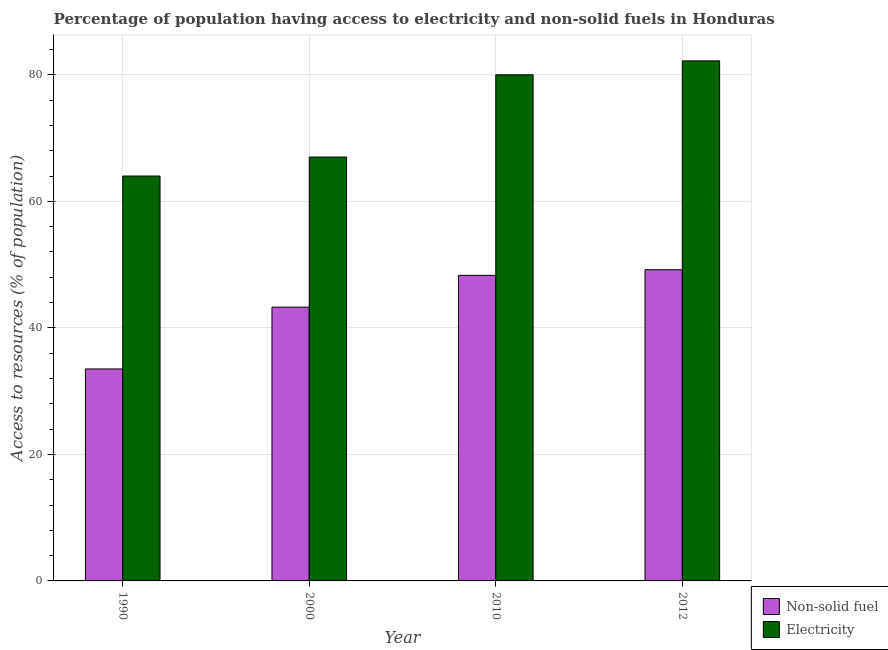How many different coloured bars are there?
Make the answer very short. 2. How many groups of bars are there?
Keep it short and to the point. 4. Are the number of bars on each tick of the X-axis equal?
Provide a short and direct response. Yes. How many bars are there on the 4th tick from the left?
Ensure brevity in your answer.  2. What is the percentage of population having access to non-solid fuel in 1990?
Offer a very short reply. 33.51. Across all years, what is the maximum percentage of population having access to electricity?
Your answer should be compact. 82.2. Across all years, what is the minimum percentage of population having access to electricity?
Your answer should be very brief. 64. In which year was the percentage of population having access to non-solid fuel maximum?
Provide a succinct answer. 2012. In which year was the percentage of population having access to non-solid fuel minimum?
Offer a very short reply. 1990. What is the total percentage of population having access to non-solid fuel in the graph?
Give a very brief answer. 174.26. What is the difference between the percentage of population having access to electricity in 1990 and that in 2010?
Make the answer very short. -16. What is the difference between the percentage of population having access to electricity in 1990 and the percentage of population having access to non-solid fuel in 2000?
Provide a short and direct response. -3. What is the average percentage of population having access to non-solid fuel per year?
Make the answer very short. 43.57. What is the ratio of the percentage of population having access to electricity in 1990 to that in 2000?
Offer a terse response. 0.96. Is the percentage of population having access to non-solid fuel in 1990 less than that in 2012?
Provide a short and direct response. Yes. What is the difference between the highest and the second highest percentage of population having access to electricity?
Ensure brevity in your answer.  2.2. What is the difference between the highest and the lowest percentage of population having access to electricity?
Ensure brevity in your answer.  18.2. What does the 2nd bar from the left in 2012 represents?
Keep it short and to the point. Electricity. What does the 1st bar from the right in 1990 represents?
Give a very brief answer. Electricity. How many bars are there?
Ensure brevity in your answer.  8. Are all the bars in the graph horizontal?
Make the answer very short. No. How many years are there in the graph?
Ensure brevity in your answer.  4. Are the values on the major ticks of Y-axis written in scientific E-notation?
Give a very brief answer. No. Where does the legend appear in the graph?
Give a very brief answer. Bottom right. How many legend labels are there?
Offer a very short reply. 2. How are the legend labels stacked?
Keep it short and to the point. Vertical. What is the title of the graph?
Your response must be concise. Percentage of population having access to electricity and non-solid fuels in Honduras. Does "Primary" appear as one of the legend labels in the graph?
Your answer should be compact. No. What is the label or title of the X-axis?
Offer a very short reply. Year. What is the label or title of the Y-axis?
Make the answer very short. Access to resources (% of population). What is the Access to resources (% of population) in Non-solid fuel in 1990?
Give a very brief answer. 33.51. What is the Access to resources (% of population) of Non-solid fuel in 2000?
Ensure brevity in your answer.  43.28. What is the Access to resources (% of population) in Electricity in 2000?
Ensure brevity in your answer.  67. What is the Access to resources (% of population) in Non-solid fuel in 2010?
Keep it short and to the point. 48.3. What is the Access to resources (% of population) in Non-solid fuel in 2012?
Provide a short and direct response. 49.19. What is the Access to resources (% of population) of Electricity in 2012?
Your answer should be very brief. 82.2. Across all years, what is the maximum Access to resources (% of population) of Non-solid fuel?
Your answer should be compact. 49.19. Across all years, what is the maximum Access to resources (% of population) in Electricity?
Make the answer very short. 82.2. Across all years, what is the minimum Access to resources (% of population) of Non-solid fuel?
Offer a very short reply. 33.51. What is the total Access to resources (% of population) in Non-solid fuel in the graph?
Provide a short and direct response. 174.26. What is the total Access to resources (% of population) of Electricity in the graph?
Offer a very short reply. 293.2. What is the difference between the Access to resources (% of population) in Non-solid fuel in 1990 and that in 2000?
Your response must be concise. -9.77. What is the difference between the Access to resources (% of population) in Electricity in 1990 and that in 2000?
Offer a terse response. -3. What is the difference between the Access to resources (% of population) of Non-solid fuel in 1990 and that in 2010?
Provide a succinct answer. -14.79. What is the difference between the Access to resources (% of population) in Non-solid fuel in 1990 and that in 2012?
Keep it short and to the point. -15.68. What is the difference between the Access to resources (% of population) of Electricity in 1990 and that in 2012?
Your answer should be very brief. -18.2. What is the difference between the Access to resources (% of population) of Non-solid fuel in 2000 and that in 2010?
Ensure brevity in your answer.  -5.02. What is the difference between the Access to resources (% of population) of Non-solid fuel in 2000 and that in 2012?
Provide a succinct answer. -5.91. What is the difference between the Access to resources (% of population) of Electricity in 2000 and that in 2012?
Offer a terse response. -15.2. What is the difference between the Access to resources (% of population) of Non-solid fuel in 2010 and that in 2012?
Provide a succinct answer. -0.89. What is the difference between the Access to resources (% of population) in Electricity in 2010 and that in 2012?
Provide a short and direct response. -2.2. What is the difference between the Access to resources (% of population) of Non-solid fuel in 1990 and the Access to resources (% of population) of Electricity in 2000?
Your response must be concise. -33.49. What is the difference between the Access to resources (% of population) in Non-solid fuel in 1990 and the Access to resources (% of population) in Electricity in 2010?
Offer a terse response. -46.49. What is the difference between the Access to resources (% of population) in Non-solid fuel in 1990 and the Access to resources (% of population) in Electricity in 2012?
Provide a succinct answer. -48.69. What is the difference between the Access to resources (% of population) of Non-solid fuel in 2000 and the Access to resources (% of population) of Electricity in 2010?
Keep it short and to the point. -36.72. What is the difference between the Access to resources (% of population) in Non-solid fuel in 2000 and the Access to resources (% of population) in Electricity in 2012?
Ensure brevity in your answer.  -38.92. What is the difference between the Access to resources (% of population) in Non-solid fuel in 2010 and the Access to resources (% of population) in Electricity in 2012?
Your response must be concise. -33.9. What is the average Access to resources (% of population) of Non-solid fuel per year?
Your response must be concise. 43.57. What is the average Access to resources (% of population) in Electricity per year?
Ensure brevity in your answer.  73.3. In the year 1990, what is the difference between the Access to resources (% of population) in Non-solid fuel and Access to resources (% of population) in Electricity?
Keep it short and to the point. -30.49. In the year 2000, what is the difference between the Access to resources (% of population) in Non-solid fuel and Access to resources (% of population) in Electricity?
Your response must be concise. -23.72. In the year 2010, what is the difference between the Access to resources (% of population) of Non-solid fuel and Access to resources (% of population) of Electricity?
Offer a very short reply. -31.7. In the year 2012, what is the difference between the Access to resources (% of population) in Non-solid fuel and Access to resources (% of population) in Electricity?
Offer a terse response. -33.01. What is the ratio of the Access to resources (% of population) in Non-solid fuel in 1990 to that in 2000?
Your answer should be compact. 0.77. What is the ratio of the Access to resources (% of population) of Electricity in 1990 to that in 2000?
Ensure brevity in your answer.  0.96. What is the ratio of the Access to resources (% of population) in Non-solid fuel in 1990 to that in 2010?
Keep it short and to the point. 0.69. What is the ratio of the Access to resources (% of population) of Non-solid fuel in 1990 to that in 2012?
Give a very brief answer. 0.68. What is the ratio of the Access to resources (% of population) in Electricity in 1990 to that in 2012?
Make the answer very short. 0.78. What is the ratio of the Access to resources (% of population) of Non-solid fuel in 2000 to that in 2010?
Provide a succinct answer. 0.9. What is the ratio of the Access to resources (% of population) in Electricity in 2000 to that in 2010?
Your answer should be compact. 0.84. What is the ratio of the Access to resources (% of population) in Non-solid fuel in 2000 to that in 2012?
Keep it short and to the point. 0.88. What is the ratio of the Access to resources (% of population) of Electricity in 2000 to that in 2012?
Make the answer very short. 0.82. What is the ratio of the Access to resources (% of population) in Non-solid fuel in 2010 to that in 2012?
Keep it short and to the point. 0.98. What is the ratio of the Access to resources (% of population) in Electricity in 2010 to that in 2012?
Provide a succinct answer. 0.97. What is the difference between the highest and the second highest Access to resources (% of population) of Non-solid fuel?
Keep it short and to the point. 0.89. What is the difference between the highest and the lowest Access to resources (% of population) of Non-solid fuel?
Your answer should be very brief. 15.68. 